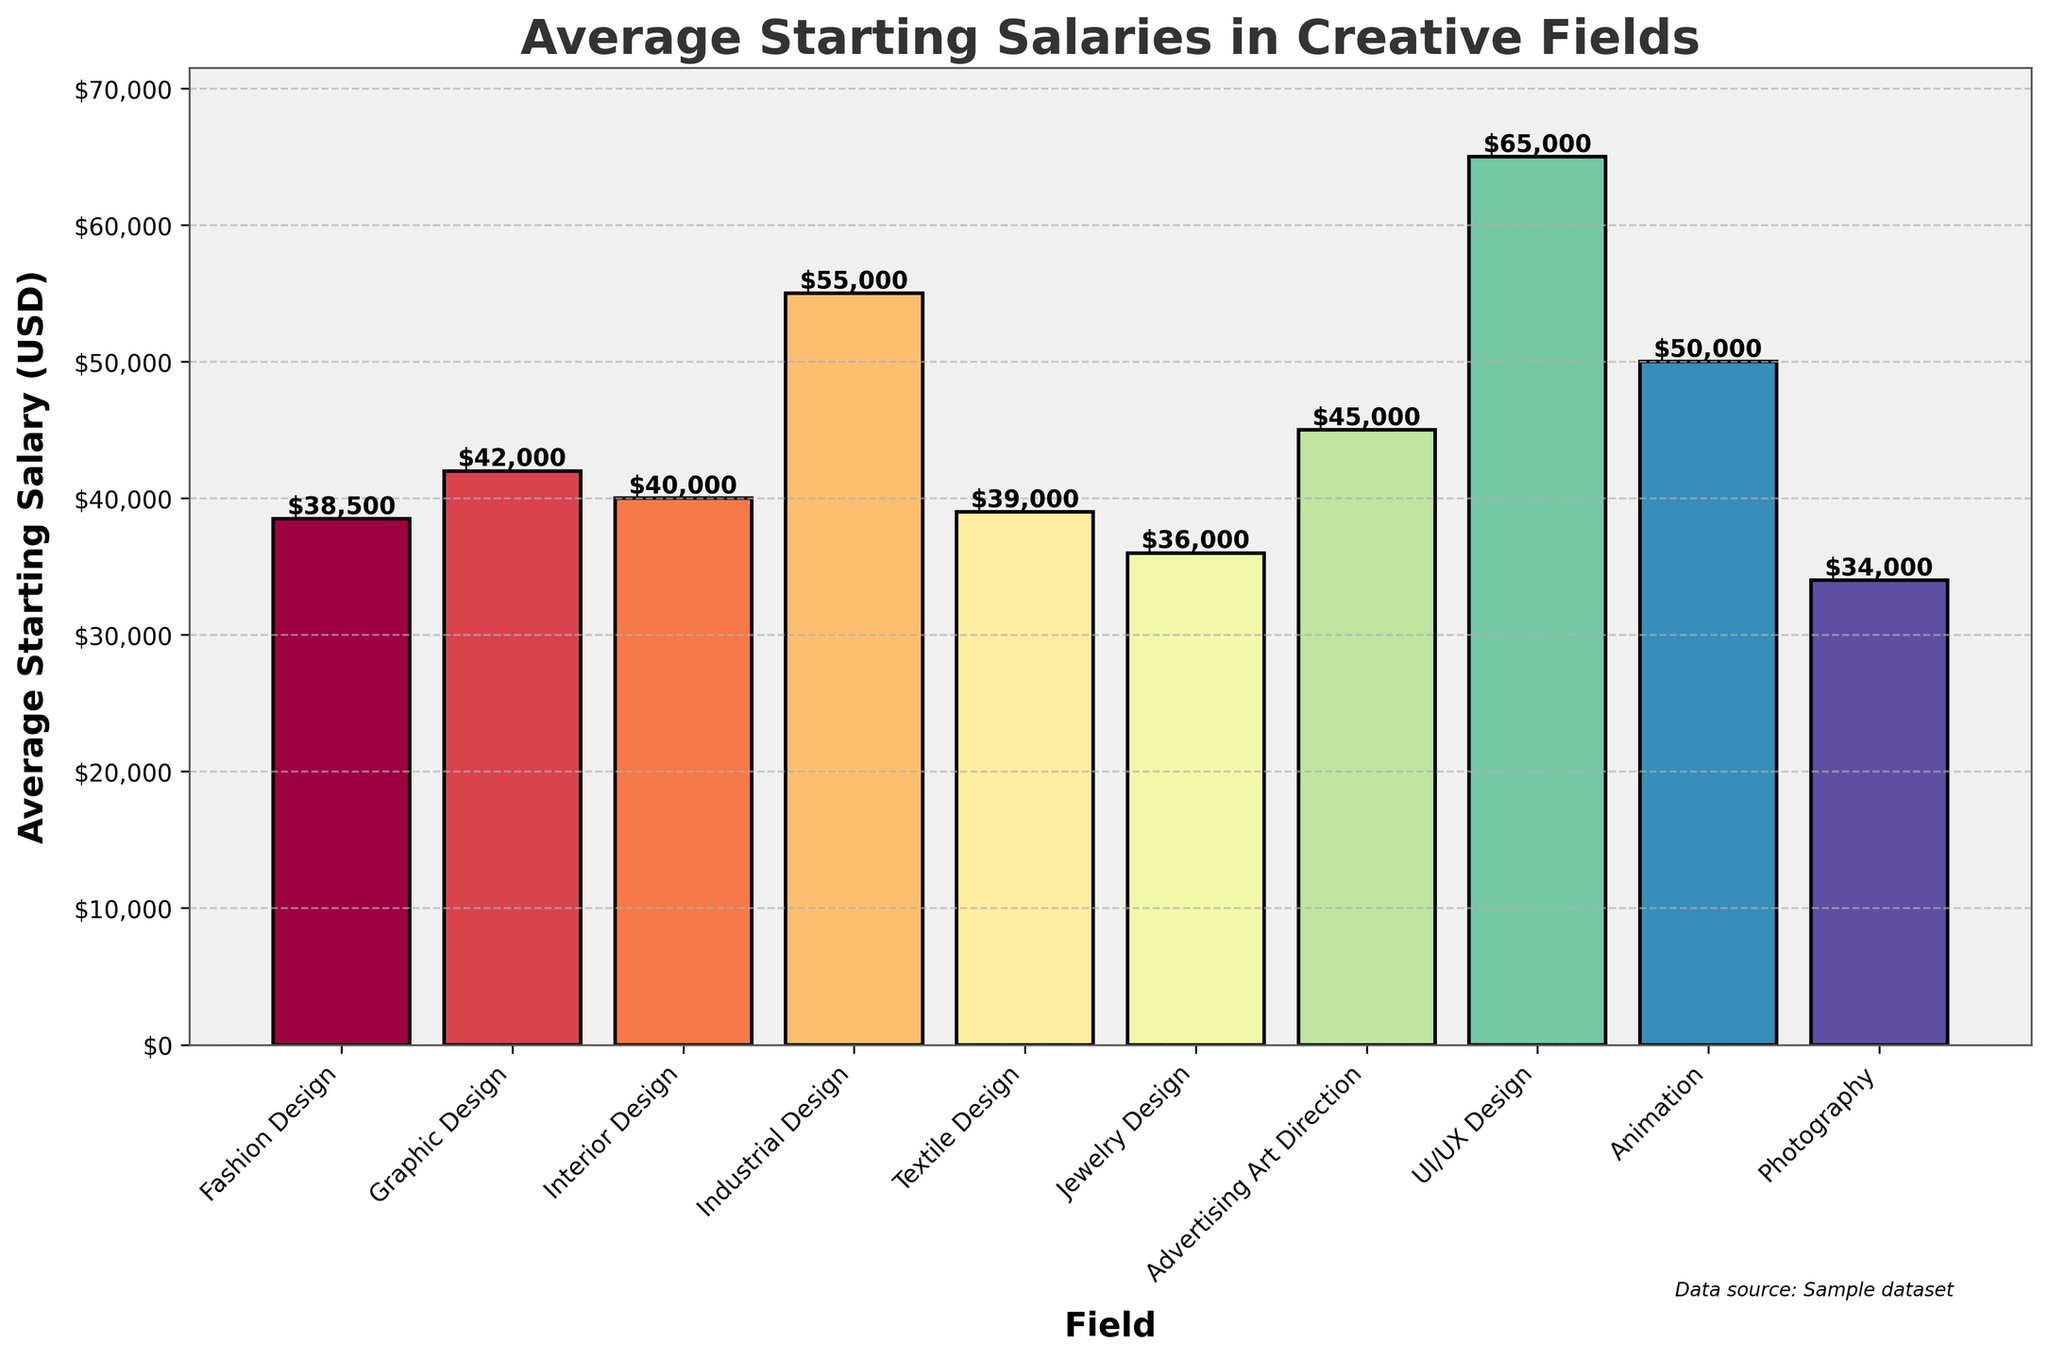Which field has the highest average starting salary? The chart shows the field of UI/UX Design with the tallest bar, indicating the highest average starting salary among the fields listed.
Answer: UI/UX Design How much higher is the average starting salary in Industrial Design compared to Fashion Design? The chart shows that the average starting salary for Industrial Design is $55,000 and for Fashion Design is $38,500. The difference is $55,000 - $38,500.
Answer: $16,500 What is the total average starting salary for Graphic Design, Interior Design, and Textile Design combined? The chart shows the salaries for Graphic Design ($42,000), Interior Design ($40,000), and Textile Design ($39,000). The combined total is $42,000 + $40,000 + $39,000.
Answer: $121,000 Which fields have average starting salaries less than $40,000? By looking at the bars that do not reach the $40,000 mark, we can identify Photography, Jewelry Design, and Fashion Design.
Answer: Photography, Jewelry Design, Fashion Design Is the average starting salary in Animation closer to Industrial Design or Graphic Design? The chart shows the average starting salary for Animation is $50,000, for Industrial Design is $55,000, and for Graphic Design is $42,000. The difference between Animation and Industrial Design is $5,000, while the difference between Animation and Graphic Design is $8,000.
Answer: Industrial Design Which field has the second lowest average starting salary, and what is the value? By ordering the bars from lowest to highest, we see that Jewelry Design is second only to Photography. The bar for Jewelry Design is labeled $36,000.
Answer: Jewelry Design, $36,000 What is the average of the starting salaries for UI/UX Design, Industrial Design, and Animation? The chart shows the average starting salaries are $65,000 for UI/UX Design, $55,000 for Industrial Design, and $50,000 for Animation. The average is calculated by ($65,000 + $55,000 + $50,000) / 3.
Answer: $56,667 How does the average starting salary of Textile Design compare to that of Fashion Design and Jewelry Design? The chart shows average salaries: Textile Design ($39,000), Fashion Design ($38,500), and Jewelry Design ($36,000). Textile Design is slightly higher than Fashion Design ($500 higher) and more than Jewelry Design ($3,000 higher).
Answer: Higher than both Which field is represented by the lightest colored bar and what is the corresponding salary? By observing the colors, the lightest colored bar corresponds to UI/UX Design. The height of the bar is $65,000.
Answer: UI/UX Design, $65,000 